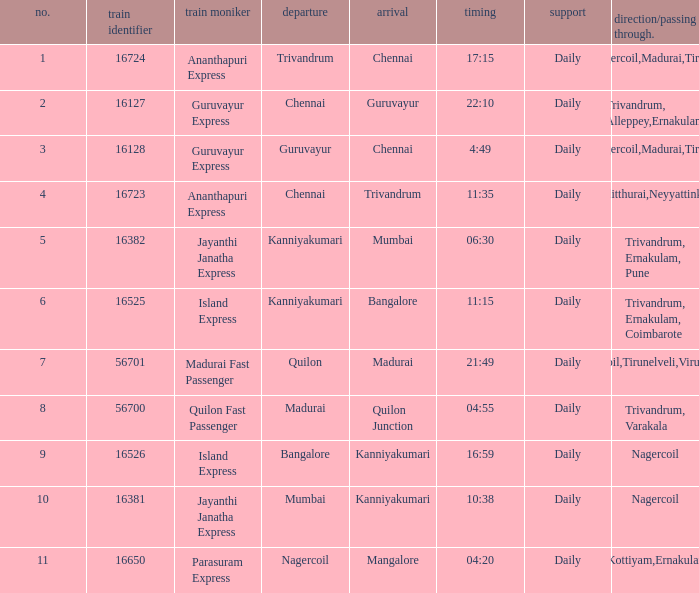What is the destination when the train number is 16526? Kanniyakumari. 